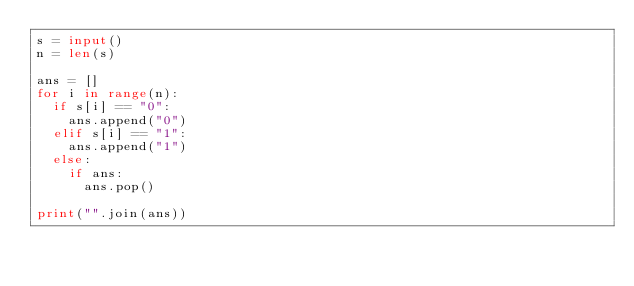<code> <loc_0><loc_0><loc_500><loc_500><_Python_>s = input()
n = len(s)

ans = []
for i in range(n):
  if s[i] == "0":
    ans.append("0")
  elif s[i] == "1":
    ans.append("1")
  else:
    if ans:
      ans.pop()
      
print("".join(ans))</code> 